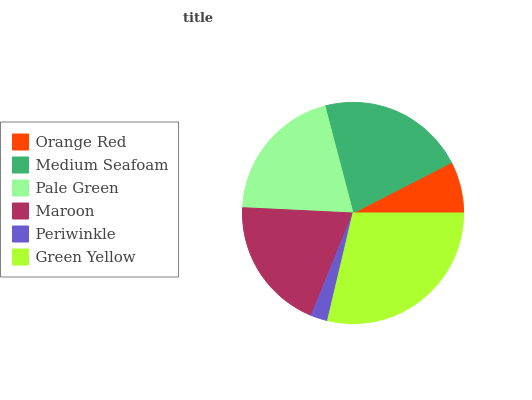Is Periwinkle the minimum?
Answer yes or no. Yes. Is Green Yellow the maximum?
Answer yes or no. Yes. Is Medium Seafoam the minimum?
Answer yes or no. No. Is Medium Seafoam the maximum?
Answer yes or no. No. Is Medium Seafoam greater than Orange Red?
Answer yes or no. Yes. Is Orange Red less than Medium Seafoam?
Answer yes or no. Yes. Is Orange Red greater than Medium Seafoam?
Answer yes or no. No. Is Medium Seafoam less than Orange Red?
Answer yes or no. No. Is Pale Green the high median?
Answer yes or no. Yes. Is Maroon the low median?
Answer yes or no. Yes. Is Maroon the high median?
Answer yes or no. No. Is Medium Seafoam the low median?
Answer yes or no. No. 